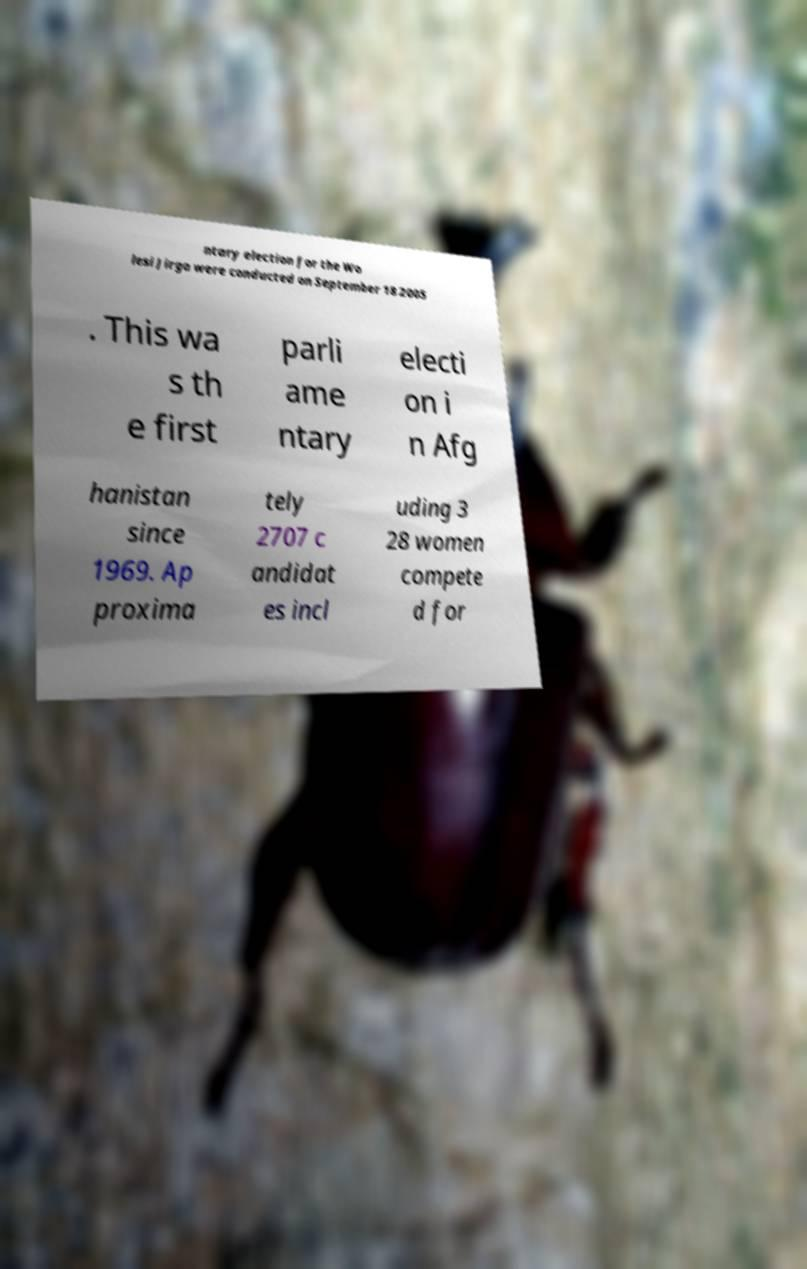Can you accurately transcribe the text from the provided image for me? ntary election for the Wo lesi Jirga were conducted on September 18 2005 . This wa s th e first parli ame ntary electi on i n Afg hanistan since 1969. Ap proxima tely 2707 c andidat es incl uding 3 28 women compete d for 